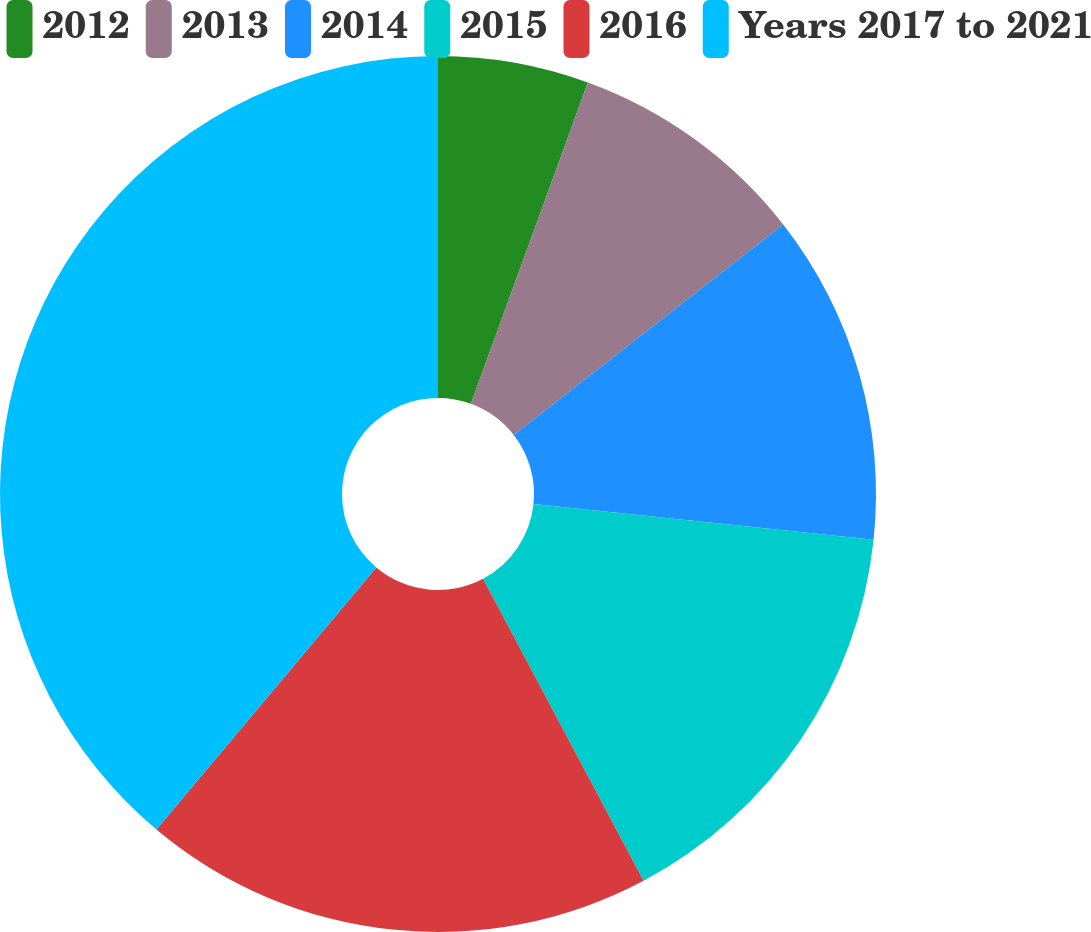Convert chart to OTSL. <chart><loc_0><loc_0><loc_500><loc_500><pie_chart><fcel>2012<fcel>2013<fcel>2014<fcel>2015<fcel>2016<fcel>Years 2017 to 2021<nl><fcel>5.56%<fcel>8.89%<fcel>12.22%<fcel>15.56%<fcel>18.89%<fcel>38.89%<nl></chart> 